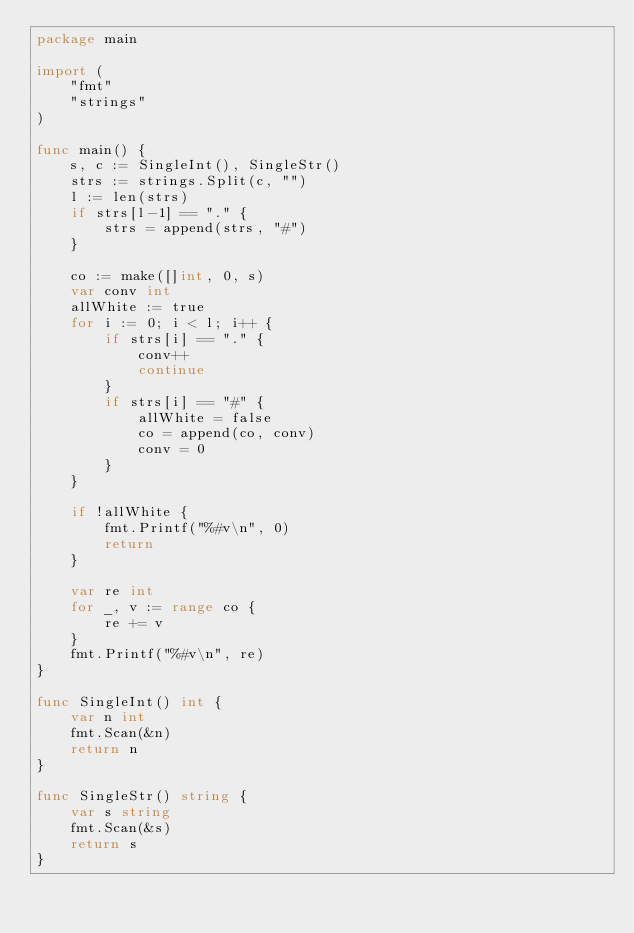Convert code to text. <code><loc_0><loc_0><loc_500><loc_500><_Go_>package main

import (
	"fmt"
	"strings"
)

func main() {
	s, c := SingleInt(), SingleStr()
	strs := strings.Split(c, "")
	l := len(strs)
	if strs[l-1] == "." {
		strs = append(strs, "#")
	}

	co := make([]int, 0, s)
	var conv int
	allWhite := true
	for i := 0; i < l; i++ {
		if strs[i] == "." {
			conv++
			continue
		}
		if strs[i] == "#" {
			allWhite = false
			co = append(co, conv)
			conv = 0
		}
	}

	if !allWhite {
		fmt.Printf("%#v\n", 0)
		return
	}

	var re int
	for _, v := range co {
		re += v
	}
	fmt.Printf("%#v\n", re)
}

func SingleInt() int {
	var n int
	fmt.Scan(&n)
	return n
}

func SingleStr() string {
	var s string
	fmt.Scan(&s)
	return s
}
</code> 